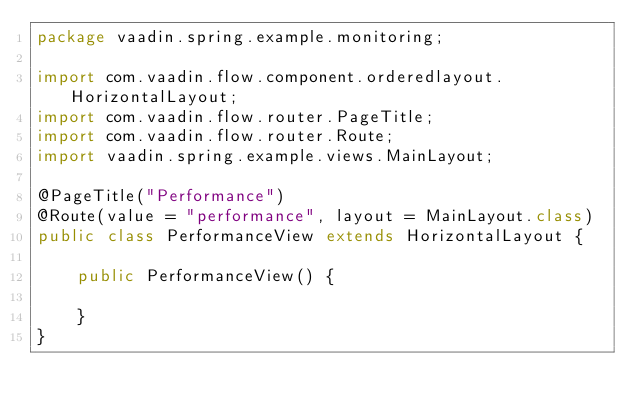<code> <loc_0><loc_0><loc_500><loc_500><_Java_>package vaadin.spring.example.monitoring;

import com.vaadin.flow.component.orderedlayout.HorizontalLayout;
import com.vaadin.flow.router.PageTitle;
import com.vaadin.flow.router.Route;
import vaadin.spring.example.views.MainLayout;

@PageTitle("Performance")
@Route(value = "performance", layout = MainLayout.class)
public class PerformanceView extends HorizontalLayout {

    public PerformanceView() {

    }
}
</code> 